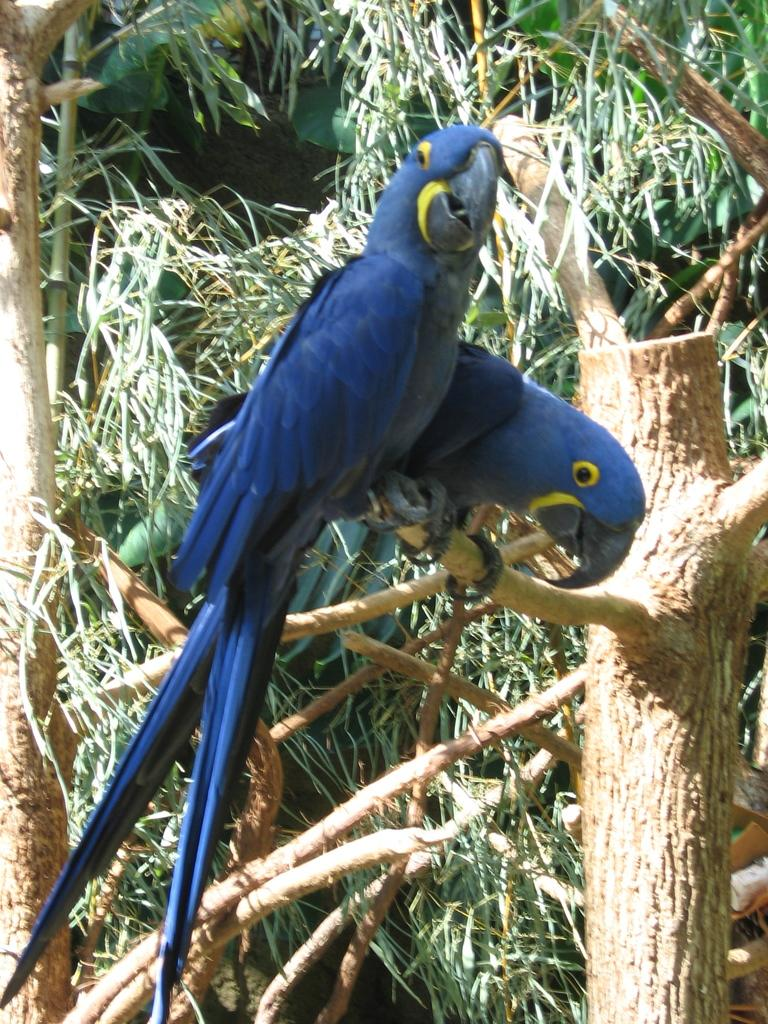What animals can be seen in the image? There are birds on a tree branch in the image. What type of vegetation is visible in the background? There are trees in the background of the image. What type of sugar can be seen growing in the field in the image? There is no field or sugar present in the image; it features birds on a tree branch and trees in the background. 